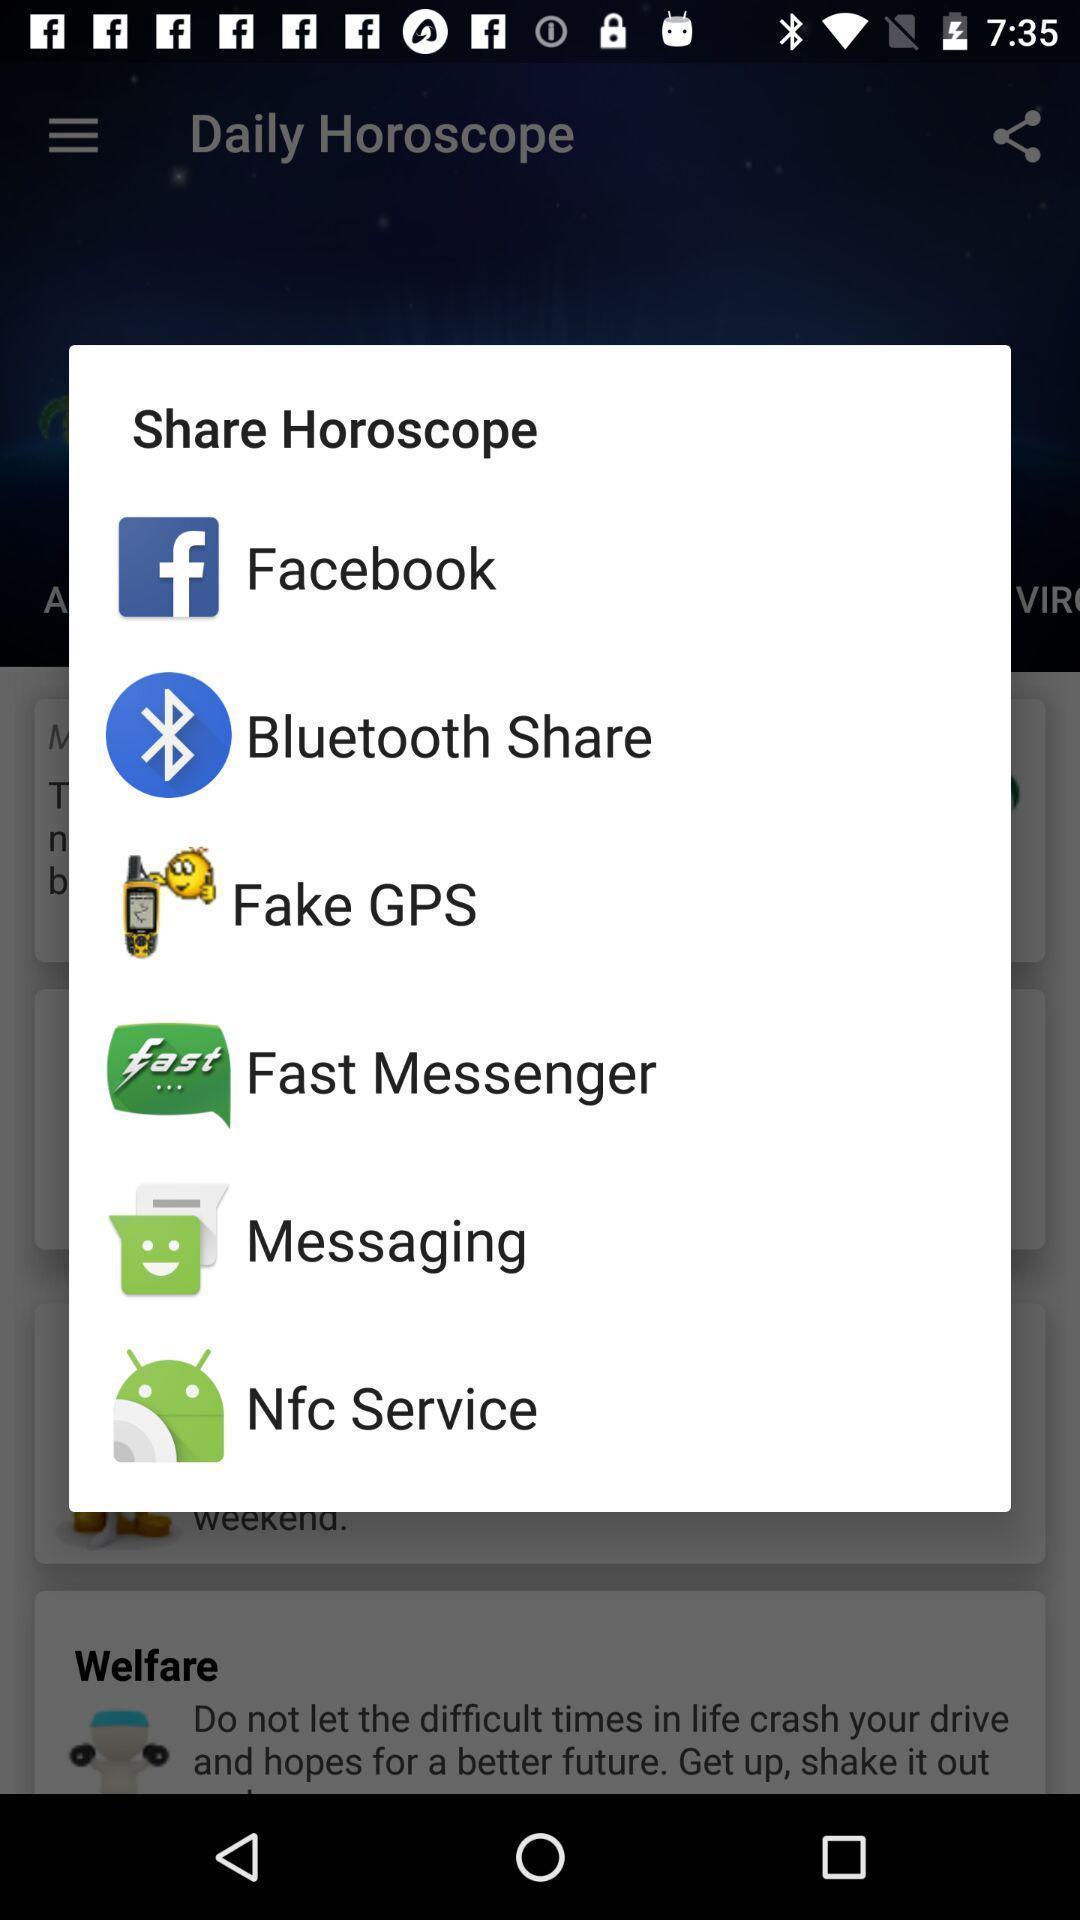Summarize the main components in this picture. Pop-up with list of application options for sharing. 